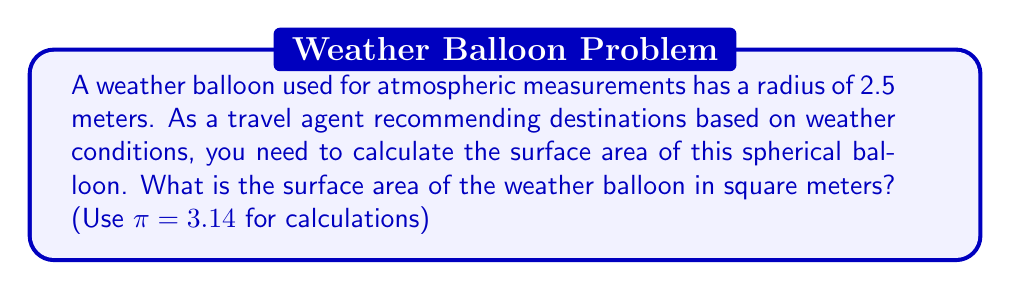Teach me how to tackle this problem. To find the surface area of a sphere, we use the formula:

$$A = 4\pi r^2$$

Where:
$A$ = surface area
$r$ = radius of the sphere

Given:
$r = 2.5$ meters
$\pi = 3.14$

Let's substitute these values into the formula:

$$\begin{align}
A &= 4\pi r^2 \\
&= 4 \times 3.14 \times (2.5)^2 \\
&= 4 \times 3.14 \times 6.25 \\
&= 78.5 \text{ m}^2
\end{align}$$

[asy]
import geometry;

size(100);
draw(circle((0,0),1), linewidth(0.7));
draw((0,0)--(1,0), arrow=Arrow(TeXHead), L=Label("$r$", position=MidPoint));
label("$2.5\text{ m}$", (0.5,0.2));
[/asy]
Answer: $78.5 \text{ m}^2$ 